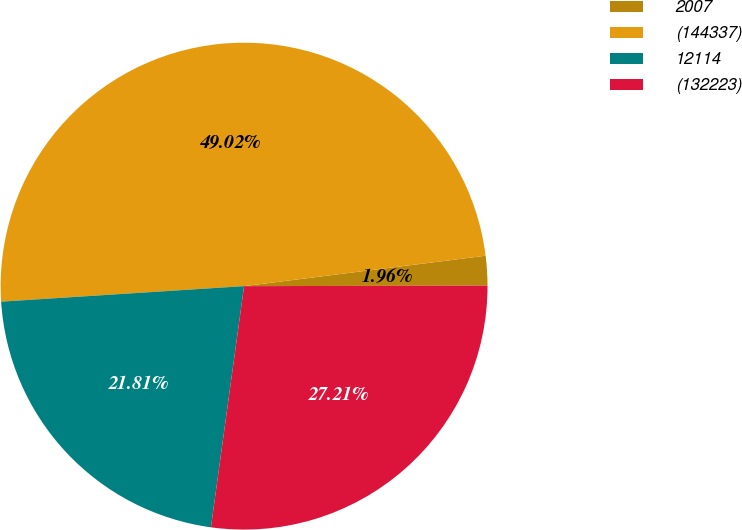<chart> <loc_0><loc_0><loc_500><loc_500><pie_chart><fcel>2007<fcel>(144337)<fcel>12114<fcel>(132223)<nl><fcel>1.96%<fcel>49.02%<fcel>21.81%<fcel>27.21%<nl></chart> 